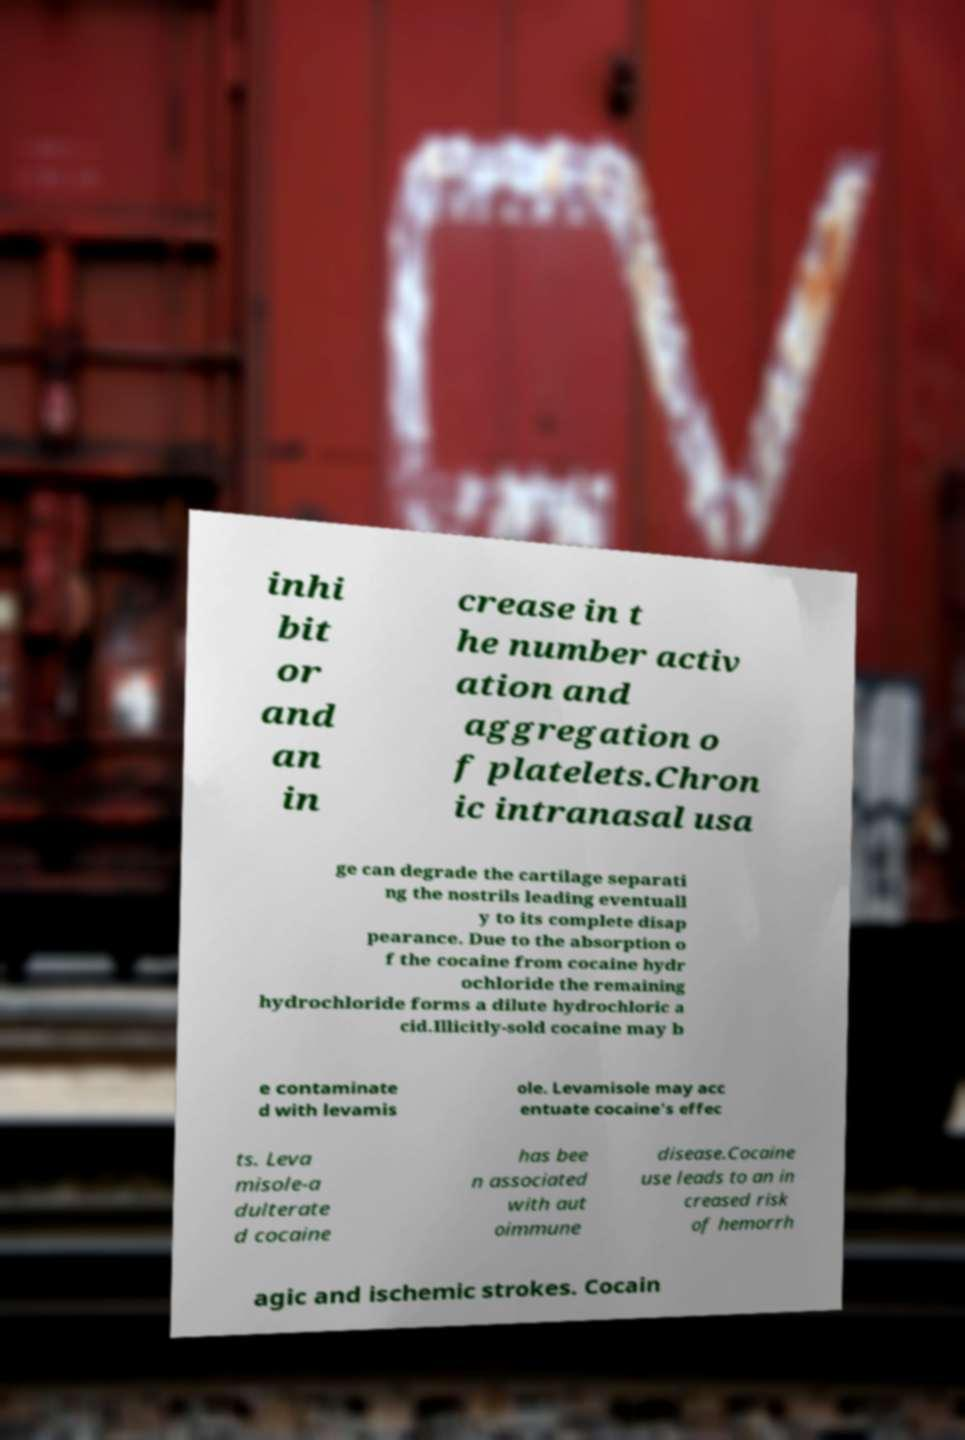Please read and relay the text visible in this image. What does it say? inhi bit or and an in crease in t he number activ ation and aggregation o f platelets.Chron ic intranasal usa ge can degrade the cartilage separati ng the nostrils leading eventuall y to its complete disap pearance. Due to the absorption o f the cocaine from cocaine hydr ochloride the remaining hydrochloride forms a dilute hydrochloric a cid.Illicitly-sold cocaine may b e contaminate d with levamis ole. Levamisole may acc entuate cocaine's effec ts. Leva misole-a dulterate d cocaine has bee n associated with aut oimmune disease.Cocaine use leads to an in creased risk of hemorrh agic and ischemic strokes. Cocain 